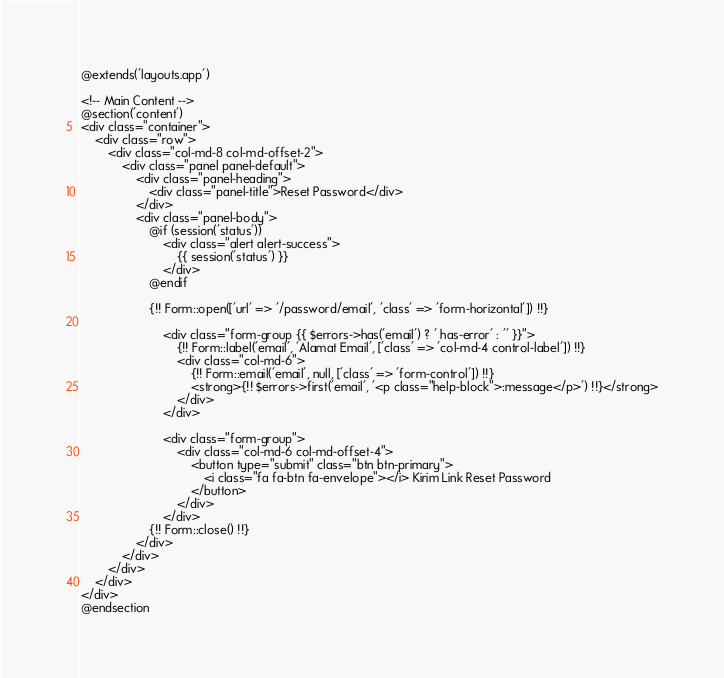Convert code to text. <code><loc_0><loc_0><loc_500><loc_500><_PHP_>@extends('layouts.app')

<!-- Main Content -->
@section('content')
<div class="container">
    <div class="row">
        <div class="col-md-8 col-md-offset-2">
            <div class="panel panel-default">
                <div class="panel-heading">
                    <div class="panel-title">Reset Password</div>
                </div>
                <div class="panel-body">
                    @if (session('status'))
                        <div class="alert alert-success">
                            {{ session('status') }}
                        </div>
                    @endif

                    {!! Form::open(['url' => '/password/email', 'class' => 'form-horizontal']) !!}

                        <div class="form-group {{ $errors->has('email') ? ' has-error' : '' }}">
                            {!! Form::label('email', 'Alamat Email', ['class' => 'col-md-4 control-label']) !!}
                            <div class="col-md-6">
                                {!! Form::email('email', null, ['class' => 'form-control']) !!}
                                <strong>{!! $errors->first('email', '<p class="help-block">:message</p>') !!}</strong>
                            </div>
                        </div>

                        <div class="form-group">
                            <div class="col-md-6 col-md-offset-4">
                                <button type="submit" class="btn btn-primary">
                                    <i class="fa fa-btn fa-envelope"></i> Kirim Link Reset Password
                                </button>
                            </div>
                        </div>
                    {!! Form::close() !!}
                </div>
            </div>
        </div>
    </div>
</div>
@endsection
</code> 